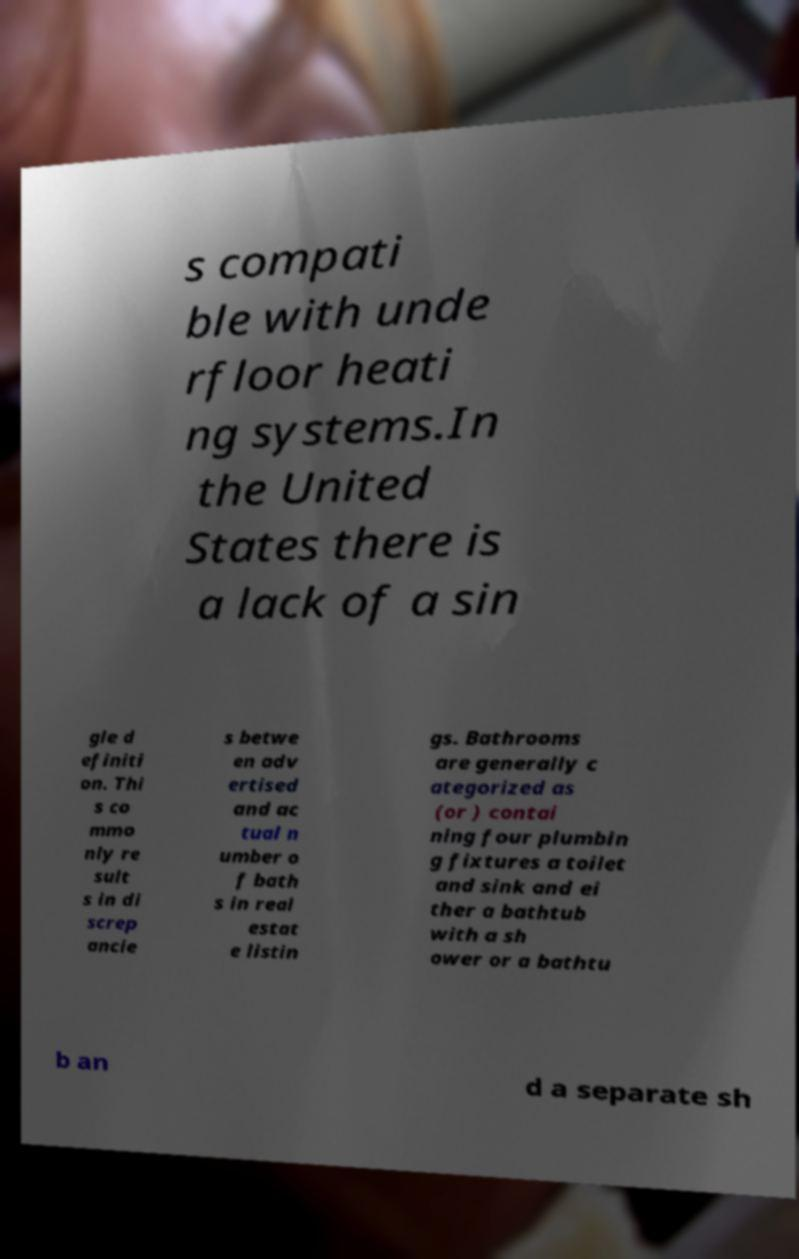Can you read and provide the text displayed in the image?This photo seems to have some interesting text. Can you extract and type it out for me? s compati ble with unde rfloor heati ng systems.In the United States there is a lack of a sin gle d efiniti on. Thi s co mmo nly re sult s in di screp ancie s betwe en adv ertised and ac tual n umber o f bath s in real estat e listin gs. Bathrooms are generally c ategorized as (or ) contai ning four plumbin g fixtures a toilet and sink and ei ther a bathtub with a sh ower or a bathtu b an d a separate sh 